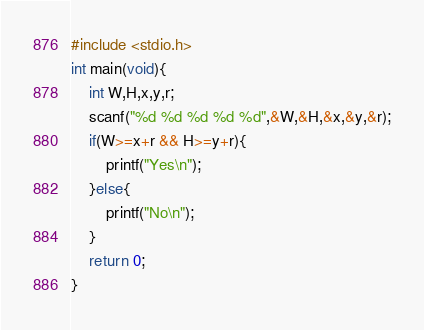<code> <loc_0><loc_0><loc_500><loc_500><_C_>#include <stdio.h>
int main(void){
	int W,H,x,y,r;
	scanf("%d %d %d %d %d",&W,&H,&x,&y,&r);
	if(W>=x+r && H>=y+r){
		printf("Yes\n");
	}else{
		printf("No\n");
	}
	return 0;
}</code> 